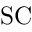<formula> <loc_0><loc_0><loc_500><loc_500>S C</formula> 